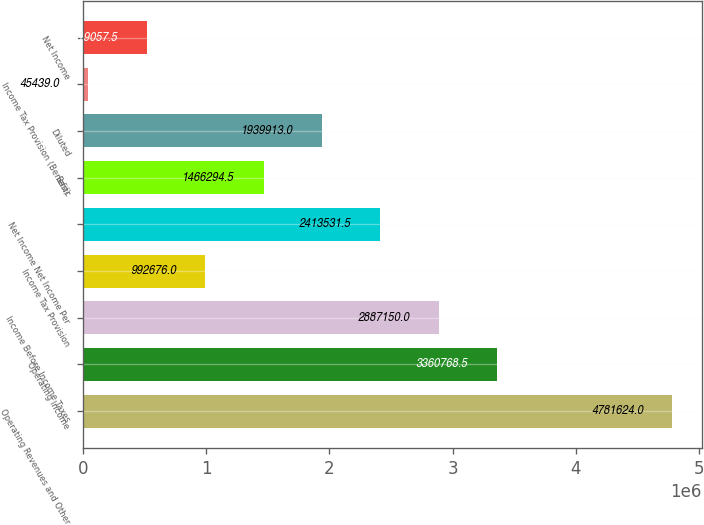Convert chart. <chart><loc_0><loc_0><loc_500><loc_500><bar_chart><fcel>Operating Revenues and Other<fcel>Operating Income<fcel>Income Before Income Taxes<fcel>Income Tax Provision<fcel>Net Income Net Income Per<fcel>Basic<fcel>Diluted<fcel>Income Tax Provision (Benefit)<fcel>Net Income<nl><fcel>4.78162e+06<fcel>3.36077e+06<fcel>2.88715e+06<fcel>992676<fcel>2.41353e+06<fcel>1.46629e+06<fcel>1.93991e+06<fcel>45439<fcel>519058<nl></chart> 